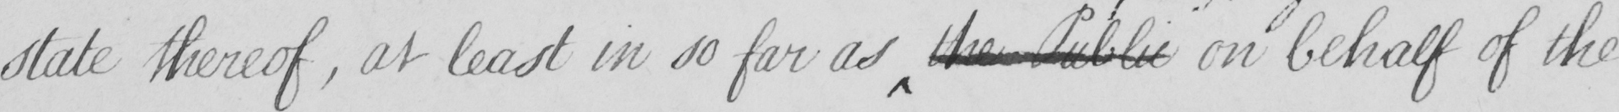Can you read and transcribe this handwriting? state thereof , at least in so far as the Public on behalf of the 